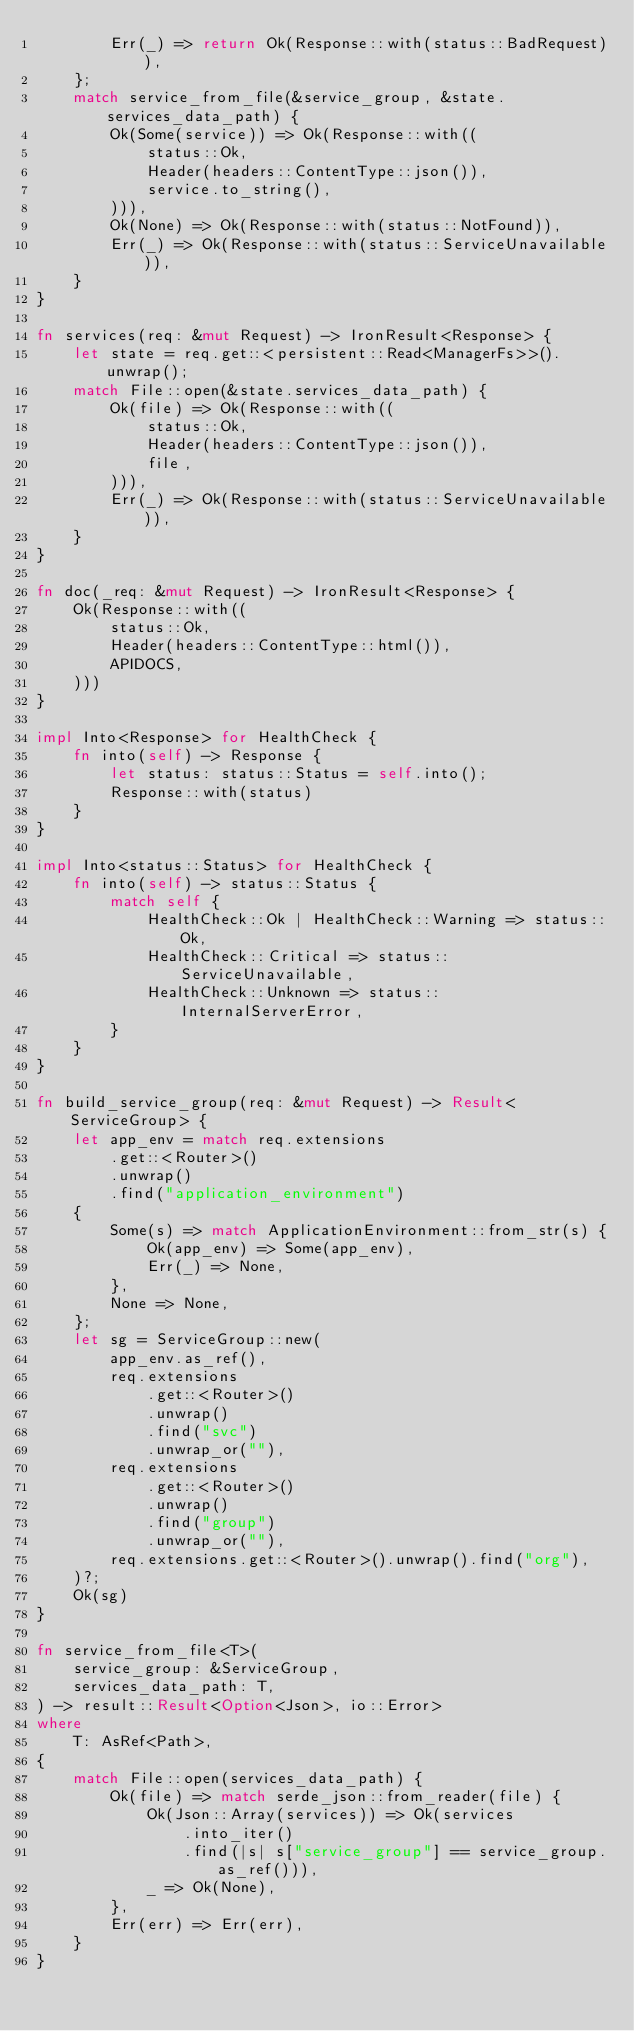<code> <loc_0><loc_0><loc_500><loc_500><_Rust_>        Err(_) => return Ok(Response::with(status::BadRequest)),
    };
    match service_from_file(&service_group, &state.services_data_path) {
        Ok(Some(service)) => Ok(Response::with((
            status::Ok,
            Header(headers::ContentType::json()),
            service.to_string(),
        ))),
        Ok(None) => Ok(Response::with(status::NotFound)),
        Err(_) => Ok(Response::with(status::ServiceUnavailable)),
    }
}

fn services(req: &mut Request) -> IronResult<Response> {
    let state = req.get::<persistent::Read<ManagerFs>>().unwrap();
    match File::open(&state.services_data_path) {
        Ok(file) => Ok(Response::with((
            status::Ok,
            Header(headers::ContentType::json()),
            file,
        ))),
        Err(_) => Ok(Response::with(status::ServiceUnavailable)),
    }
}

fn doc(_req: &mut Request) -> IronResult<Response> {
    Ok(Response::with((
        status::Ok,
        Header(headers::ContentType::html()),
        APIDOCS,
    )))
}

impl Into<Response> for HealthCheck {
    fn into(self) -> Response {
        let status: status::Status = self.into();
        Response::with(status)
    }
}

impl Into<status::Status> for HealthCheck {
    fn into(self) -> status::Status {
        match self {
            HealthCheck::Ok | HealthCheck::Warning => status::Ok,
            HealthCheck::Critical => status::ServiceUnavailable,
            HealthCheck::Unknown => status::InternalServerError,
        }
    }
}

fn build_service_group(req: &mut Request) -> Result<ServiceGroup> {
    let app_env = match req.extensions
        .get::<Router>()
        .unwrap()
        .find("application_environment")
    {
        Some(s) => match ApplicationEnvironment::from_str(s) {
            Ok(app_env) => Some(app_env),
            Err(_) => None,
        },
        None => None,
    };
    let sg = ServiceGroup::new(
        app_env.as_ref(),
        req.extensions
            .get::<Router>()
            .unwrap()
            .find("svc")
            .unwrap_or(""),
        req.extensions
            .get::<Router>()
            .unwrap()
            .find("group")
            .unwrap_or(""),
        req.extensions.get::<Router>().unwrap().find("org"),
    )?;
    Ok(sg)
}

fn service_from_file<T>(
    service_group: &ServiceGroup,
    services_data_path: T,
) -> result::Result<Option<Json>, io::Error>
where
    T: AsRef<Path>,
{
    match File::open(services_data_path) {
        Ok(file) => match serde_json::from_reader(file) {
            Ok(Json::Array(services)) => Ok(services
                .into_iter()
                .find(|s| s["service_group"] == service_group.as_ref())),
            _ => Ok(None),
        },
        Err(err) => Err(err),
    }
}
</code> 